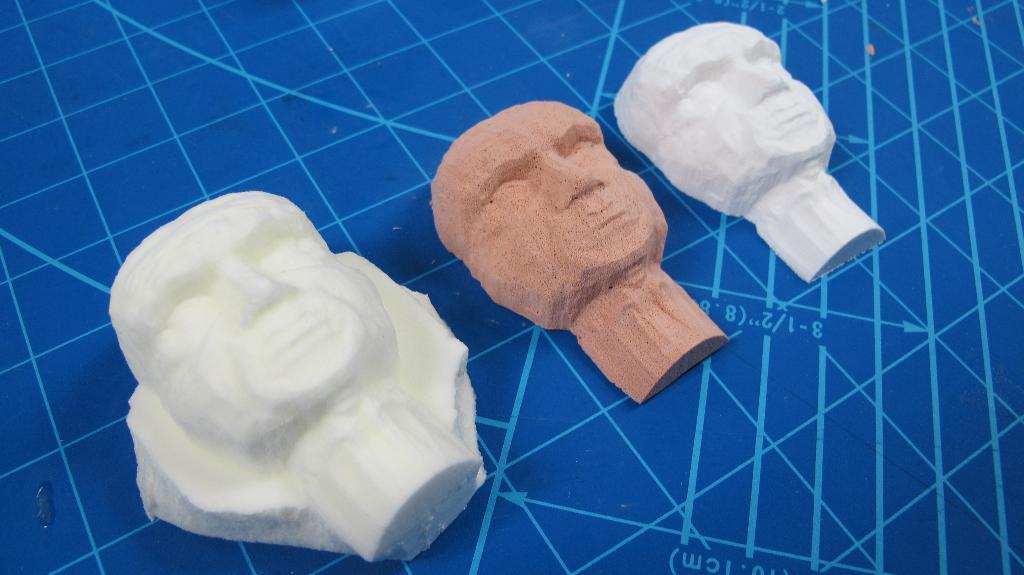Can you describe this image briefly? As we can see in the image there are statues of human faces. 